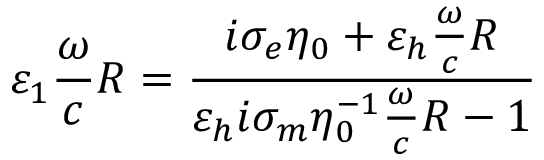<formula> <loc_0><loc_0><loc_500><loc_500>\varepsilon _ { 1 } \frac { \omega } { c } R = \frac { i \sigma _ { e } \eta _ { 0 } + \varepsilon _ { h } \frac { \omega } { c } R } { \varepsilon _ { h } i \sigma _ { m } \eta _ { 0 } ^ { - 1 } \frac { \omega } { c } R - 1 }</formula> 